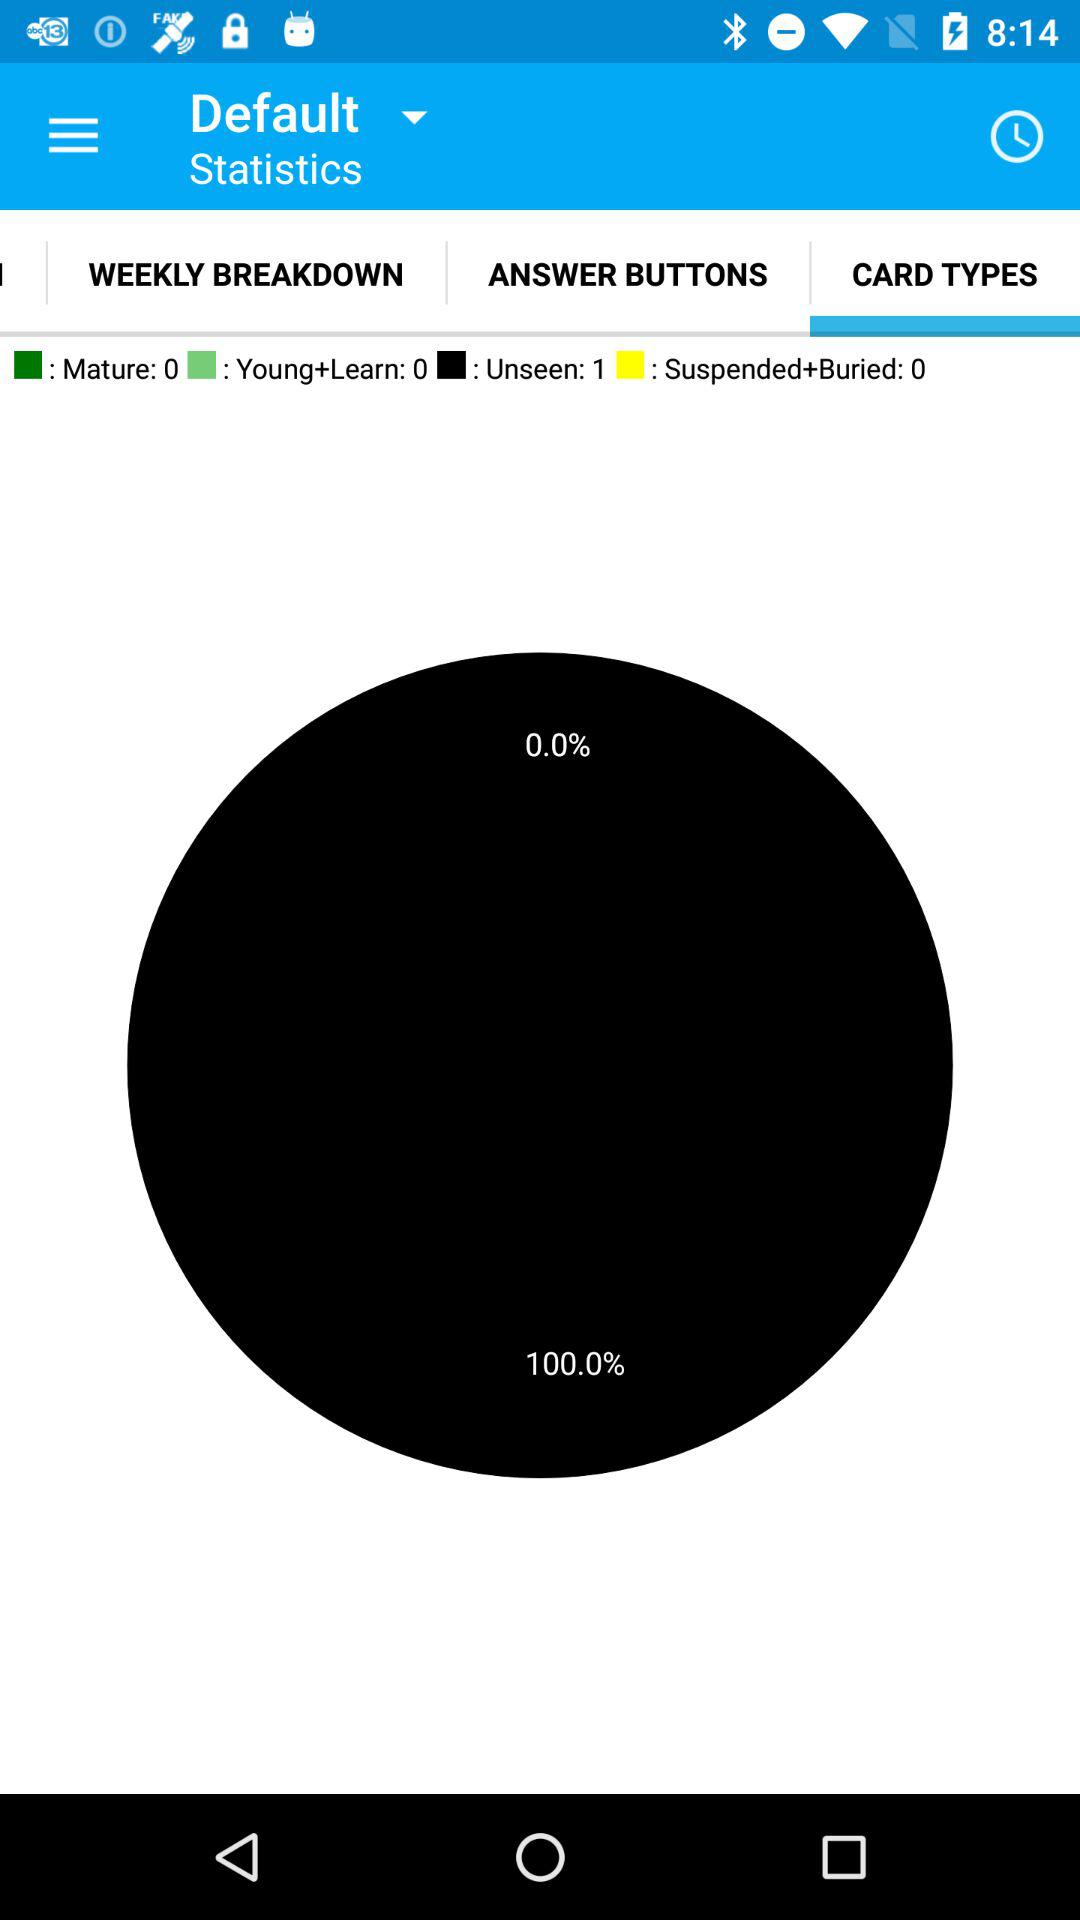What are the statistics for the "Mature"? There are zero statistics for the "Mature". 